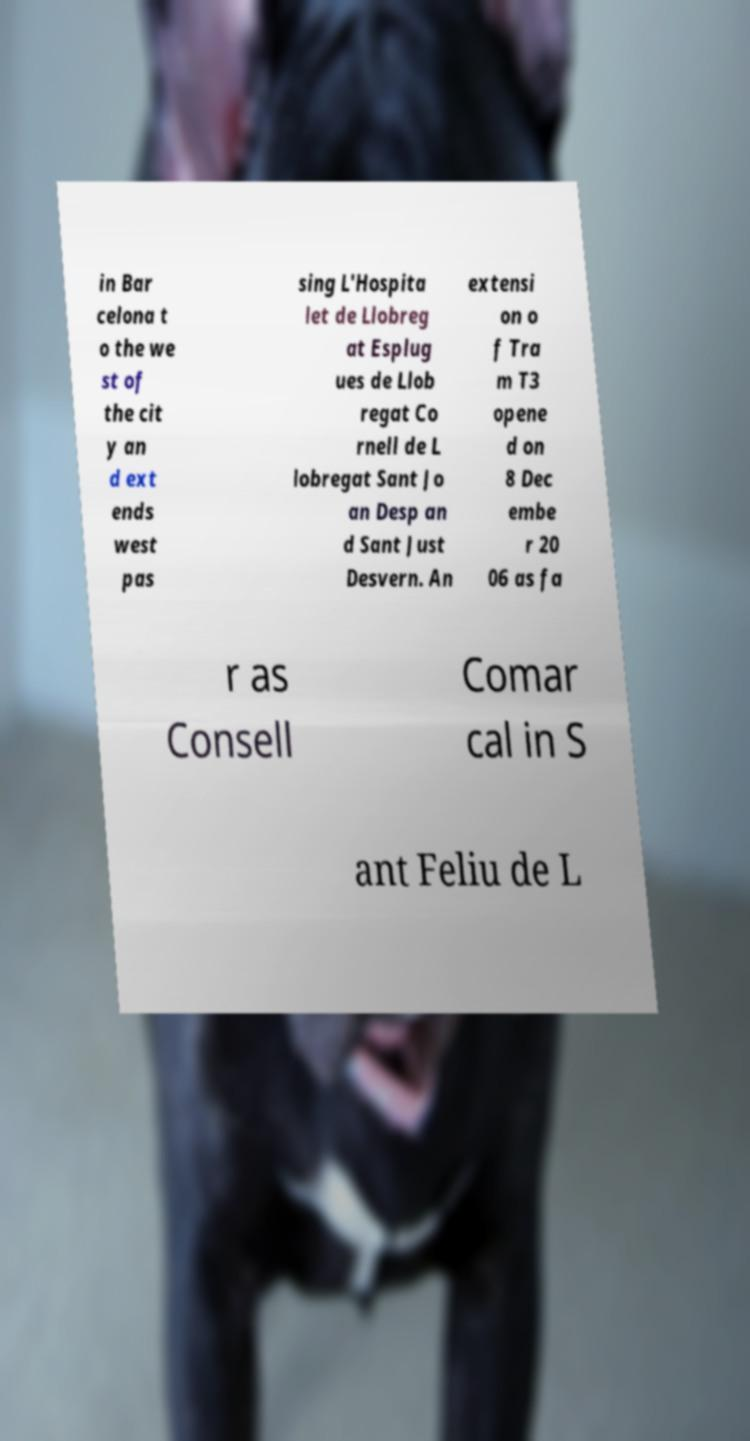What messages or text are displayed in this image? I need them in a readable, typed format. in Bar celona t o the we st of the cit y an d ext ends west pas sing L'Hospita let de Llobreg at Esplug ues de Llob regat Co rnell de L lobregat Sant Jo an Desp an d Sant Just Desvern. An extensi on o f Tra m T3 opene d on 8 Dec embe r 20 06 as fa r as Consell Comar cal in S ant Feliu de L 